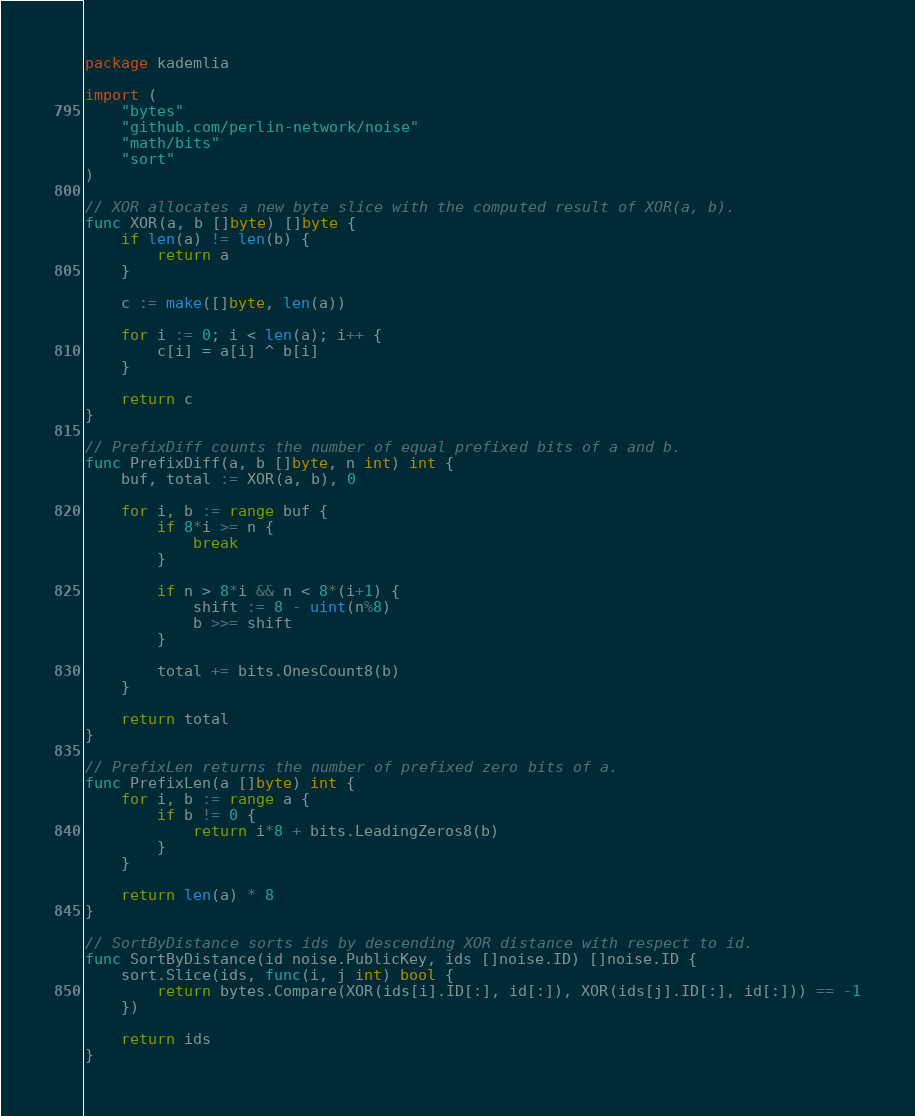Convert code to text. <code><loc_0><loc_0><loc_500><loc_500><_Go_>package kademlia

import (
	"bytes"
	"github.com/perlin-network/noise"
	"math/bits"
	"sort"
)

// XOR allocates a new byte slice with the computed result of XOR(a, b).
func XOR(a, b []byte) []byte {
	if len(a) != len(b) {
		return a
	}

	c := make([]byte, len(a))

	for i := 0; i < len(a); i++ {
		c[i] = a[i] ^ b[i]
	}

	return c
}

// PrefixDiff counts the number of equal prefixed bits of a and b.
func PrefixDiff(a, b []byte, n int) int {
	buf, total := XOR(a, b), 0

	for i, b := range buf {
		if 8*i >= n {
			break
		}

		if n > 8*i && n < 8*(i+1) {
			shift := 8 - uint(n%8)
			b >>= shift
		}

		total += bits.OnesCount8(b)
	}

	return total
}

// PrefixLen returns the number of prefixed zero bits of a.
func PrefixLen(a []byte) int {
	for i, b := range a {
		if b != 0 {
			return i*8 + bits.LeadingZeros8(b)
		}
	}

	return len(a) * 8
}

// SortByDistance sorts ids by descending XOR distance with respect to id.
func SortByDistance(id noise.PublicKey, ids []noise.ID) []noise.ID {
	sort.Slice(ids, func(i, j int) bool {
		return bytes.Compare(XOR(ids[i].ID[:], id[:]), XOR(ids[j].ID[:], id[:])) == -1
	})

	return ids
}
</code> 